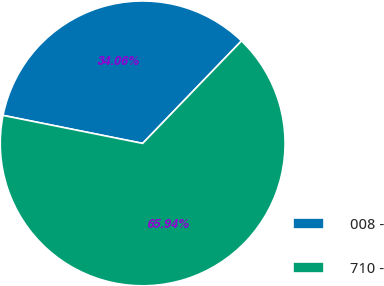<chart> <loc_0><loc_0><loc_500><loc_500><pie_chart><fcel>008 -<fcel>710 -<nl><fcel>34.06%<fcel>65.94%<nl></chart> 